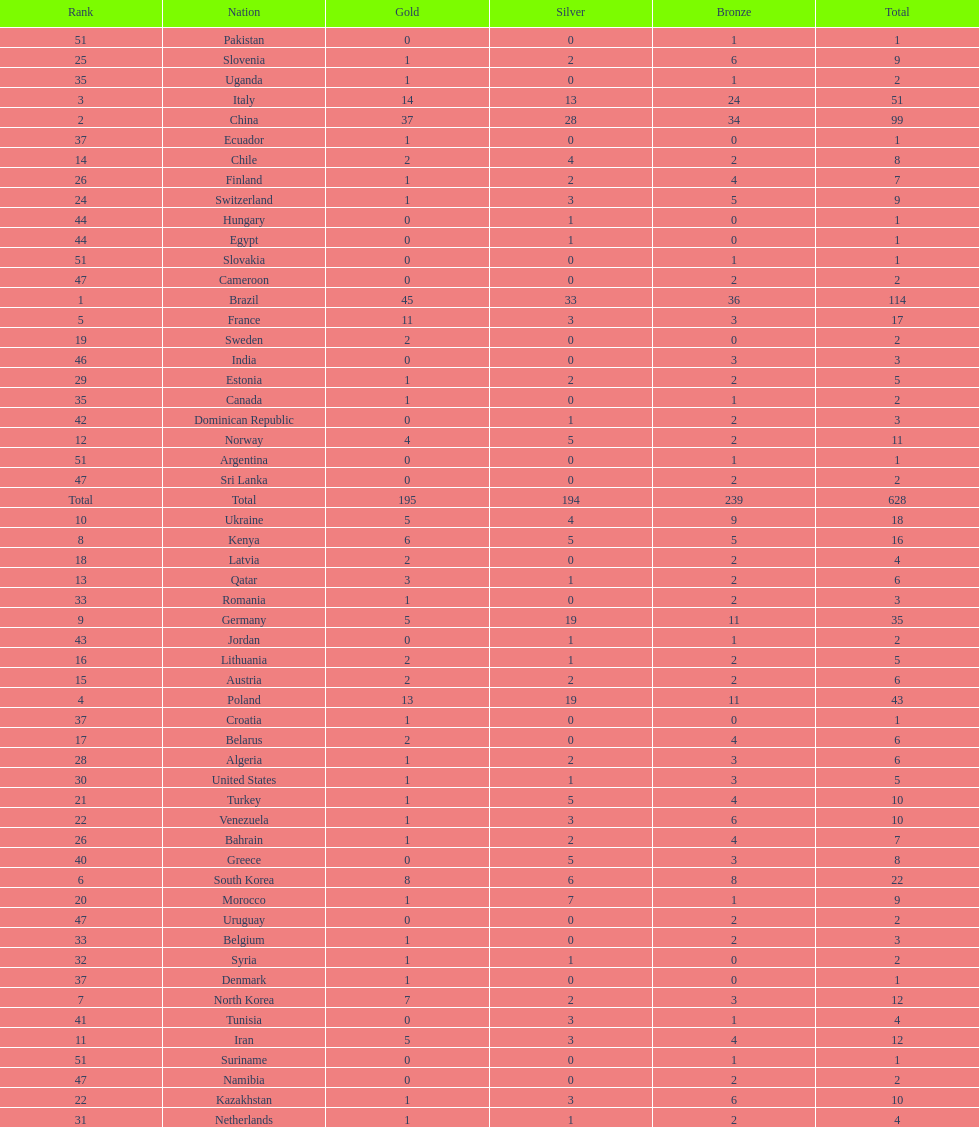Who only won 13 silver medals? Italy. 